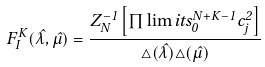Convert formula to latex. <formula><loc_0><loc_0><loc_500><loc_500>\ F _ { I } ^ { K } ( \hat { \lambda } , \hat { \mu } ) = \frac { Z ^ { - 1 } _ { N } \left [ \prod \lim i t s _ { 0 } ^ { N + K - 1 } c _ { j } ^ { 2 } \right ] } { \triangle ( \hat { \lambda } ) \triangle ( \hat { \mu } ) } \,</formula> 